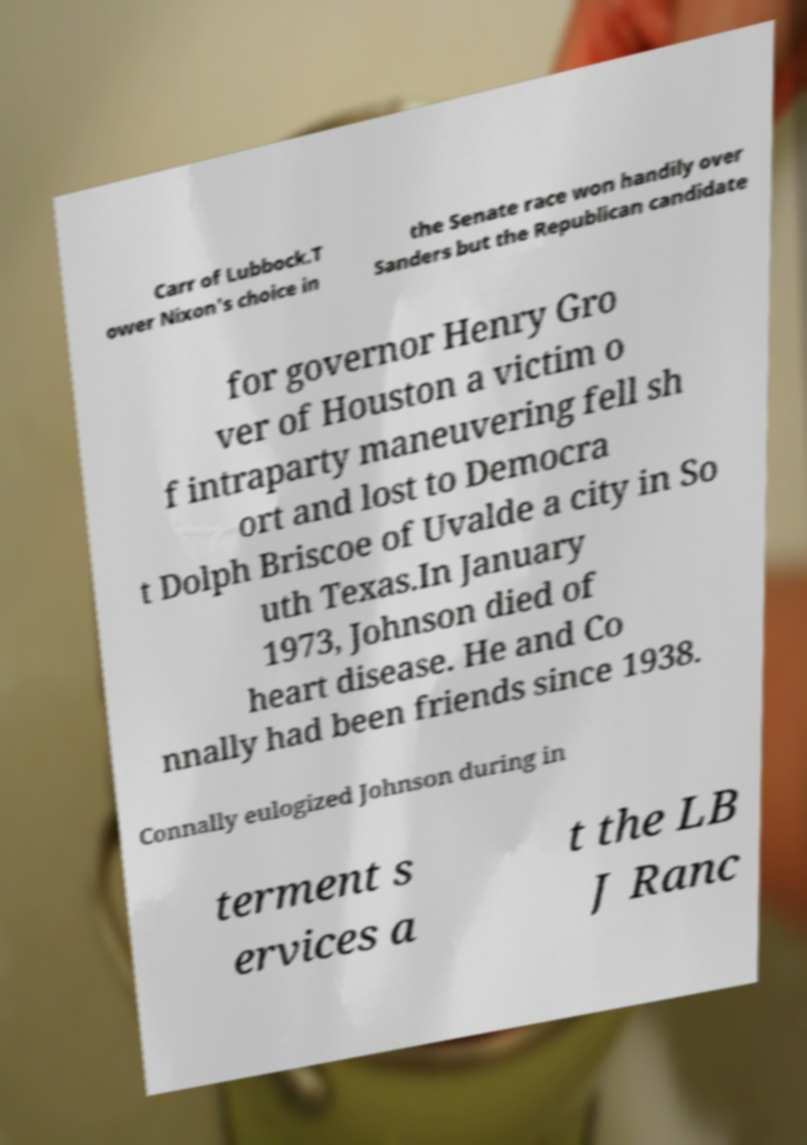Could you assist in decoding the text presented in this image and type it out clearly? Carr of Lubbock.T ower Nixon's choice in the Senate race won handily over Sanders but the Republican candidate for governor Henry Gro ver of Houston a victim o f intraparty maneuvering fell sh ort and lost to Democra t Dolph Briscoe of Uvalde a city in So uth Texas.In January 1973, Johnson died of heart disease. He and Co nnally had been friends since 1938. Connally eulogized Johnson during in terment s ervices a t the LB J Ranc 